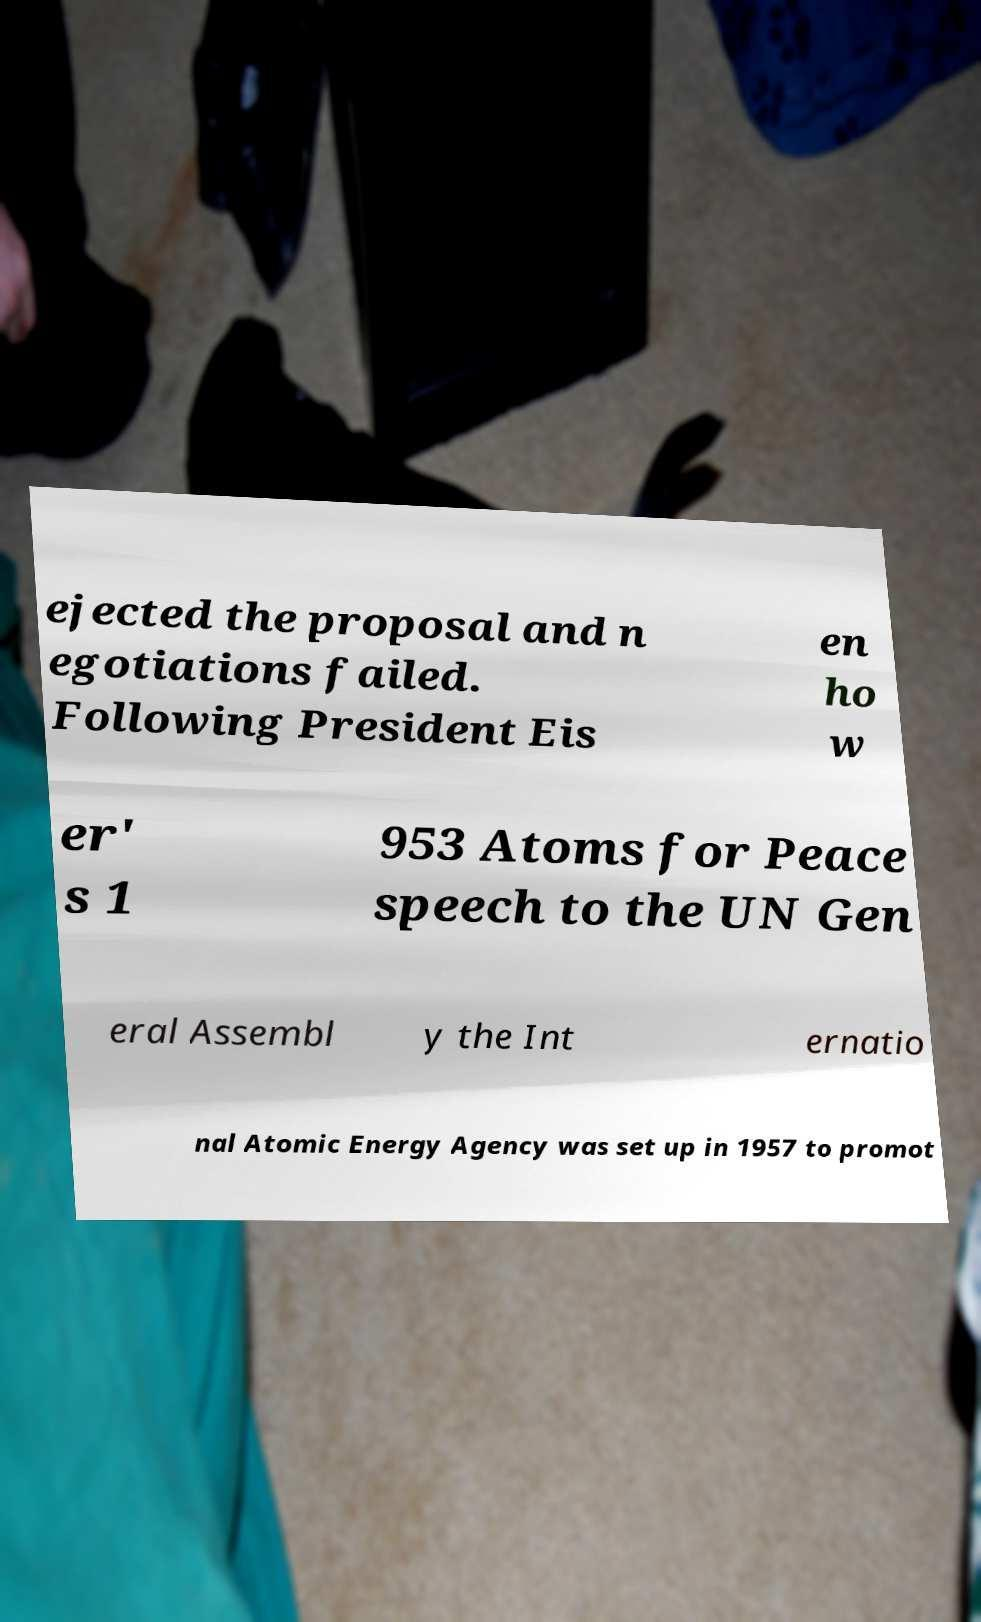Could you assist in decoding the text presented in this image and type it out clearly? ejected the proposal and n egotiations failed. Following President Eis en ho w er' s 1 953 Atoms for Peace speech to the UN Gen eral Assembl y the Int ernatio nal Atomic Energy Agency was set up in 1957 to promot 